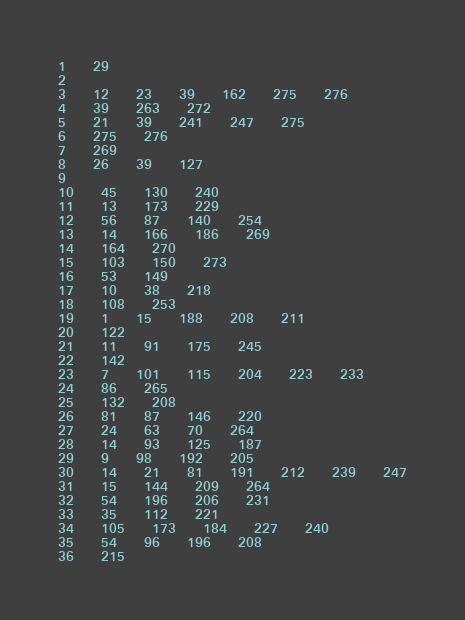Convert code to text. <code><loc_0><loc_0><loc_500><loc_500><_Perl_>1	29
2
3	12	23	39	162	275	276
4	39	263	272
5	21	39	241	247	275
6	275	276
7	269
8	26	39	127
9
10	45	130	240
11	13	173	229
12	56	87	140	254
13	14	166	186	269
14	164	270
15	103	150	273
16	53	149
17	10	38	218
18	108	253
19	1	15	188	208	211
20	122
21	11	91	175	245
22	142
23	7	101	115	204	223	233
24	86	265
25	132	208
26	81	87	146	220
27	24	63	70	264
28	14	93	125	187
29	9	98	192	205
30	14	21	81	191	212	239	247
31	15	144	209	264
32	54	196	206	231
33	35	112	221
34	105	173	184	227	240
35	54	96	196	208
36	215</code> 